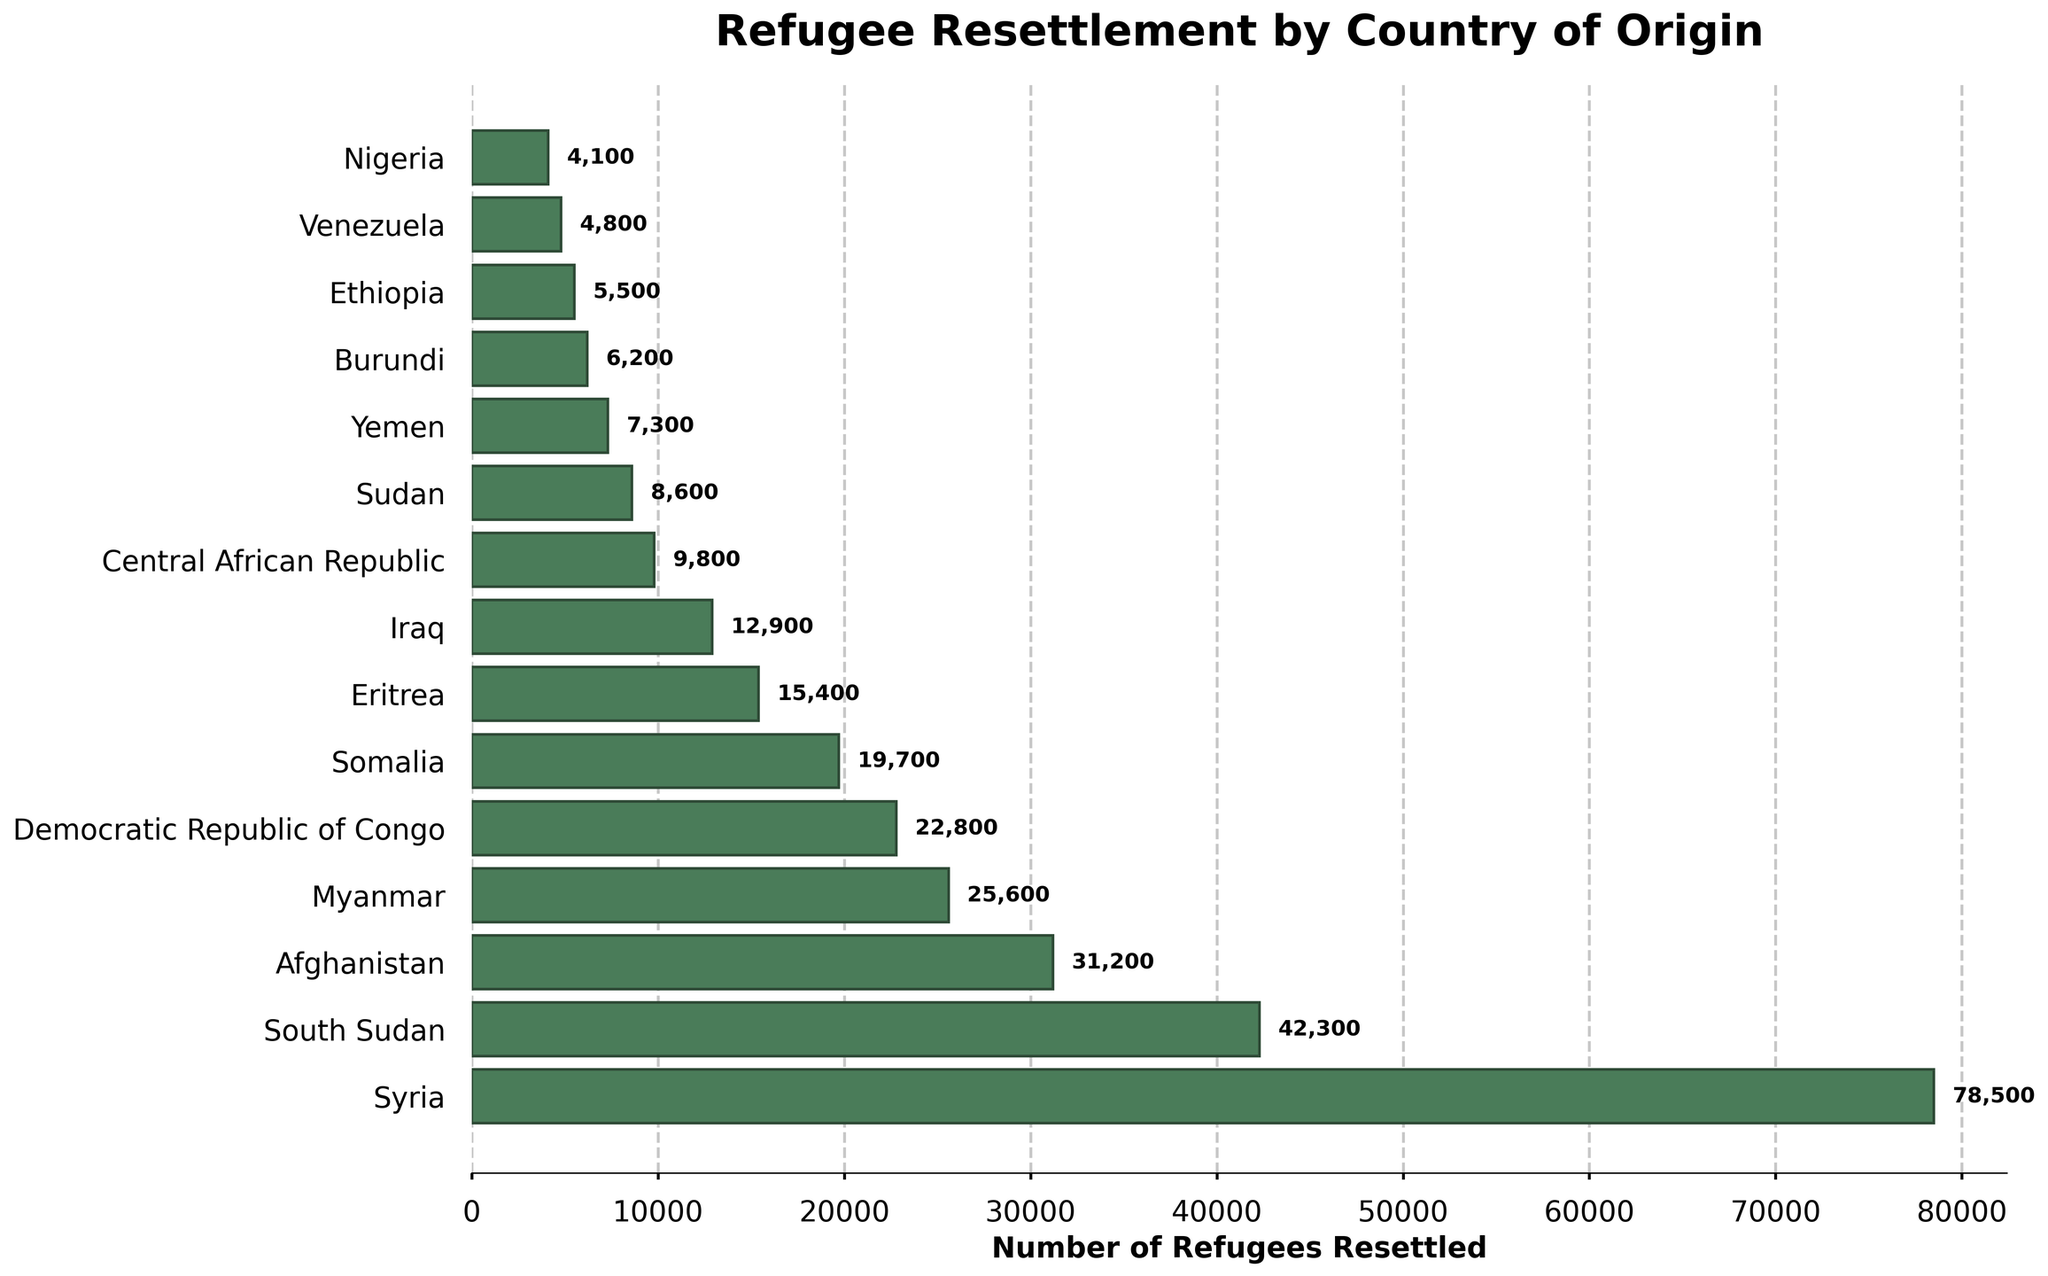Which country has the highest number of refugees resettled? The bar for Syria extends furthest to the right, indicating the highest number of refugees resettled.
Answer: Syria How many more refugees were resettled from South Sudan compared to Yemen? South Sudan has 42,300 refugees resettled, and Yemen has 7,300. The difference is calculated as 42,300 - 7,300.
Answer: 35,000 Are there more refugees resettled from Afghanistan or from Myanmar? By comparing the lengths of the bars, the bar for Afghanistan is longer than the bar for Myanmar.
Answer: Afghanistan Which country has the smallest number of refugees resettled? The bar corresponding to Nigeria is the shortest, indicating the smallest number of refugees resettled.
Answer: Nigeria What is the total number of refugees resettled from Syria, Afghanistan, and Iraq? Adding the numbers for Syria (78,500), Afghanistan (31,200), and Iraq (12,900): 78,500 + 31,200 + 12,900.
Answer: 122,600 How many refugees were resettled from the Democratic Republic of Congo and Somalia combined? Adding the numbers for the Democratic Republic of Congo (22,800) and Somalia (19,700): 22,800 + 19,700.
Answer: 42,500 Which two countries have a similar number of refugees resettled, around 15,000? The bars for Eritrea (15,400) and Iraq (12,900) are closest in length and around the 15,000 mark.
Answer: Eritrea and Iraq How many more refugees were resettled from Syria compared to Afghanistan? Syria has 78,500 refugees resettled while Afghanistan has 31,200. The difference is 78,500 - 31,200.
Answer: 47,300 Which country's refugee resettlement number is closest to 10,000? The bar for Central African Republic is closest to the 10,000 mark with 9,800 refugees resettled.
Answer: Central African Republic Which has more resettled refugees, Sudan or Ethiopia? Comparing the lengths of the bars, Sudan (8,600) has more resettled refugees than Ethiopia (5,500).
Answer: Sudan 